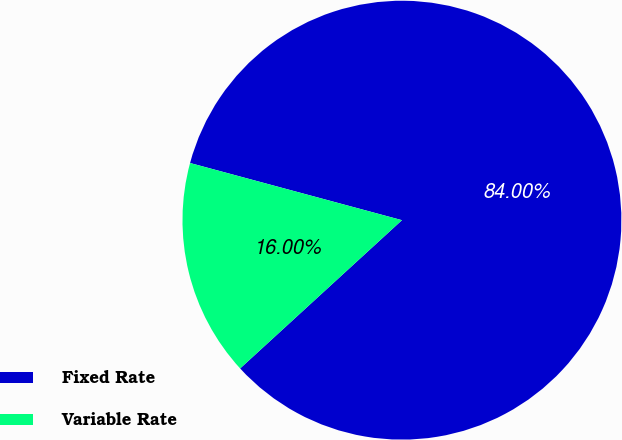Convert chart. <chart><loc_0><loc_0><loc_500><loc_500><pie_chart><fcel>Fixed Rate<fcel>Variable Rate<nl><fcel>84.0%<fcel>16.0%<nl></chart> 